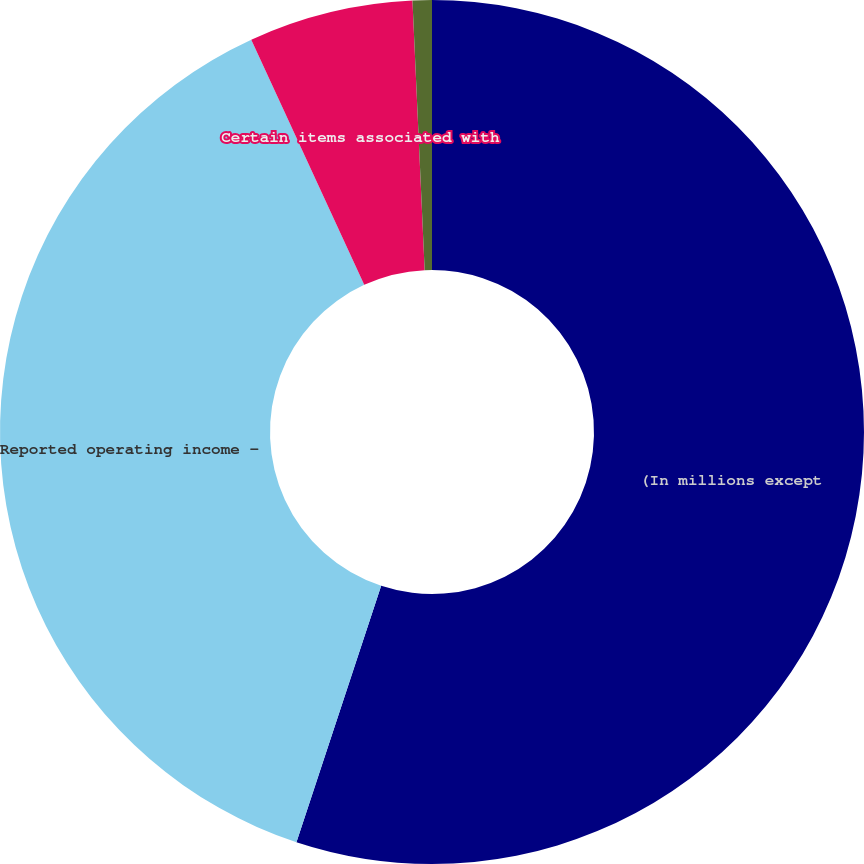Convert chart to OTSL. <chart><loc_0><loc_0><loc_500><loc_500><pie_chart><fcel>(In millions except<fcel>Reported operating income -<fcel>Certain items associated with<fcel>Non-GAAP adjusted operating<nl><fcel>55.08%<fcel>38.05%<fcel>6.15%<fcel>0.72%<nl></chart> 